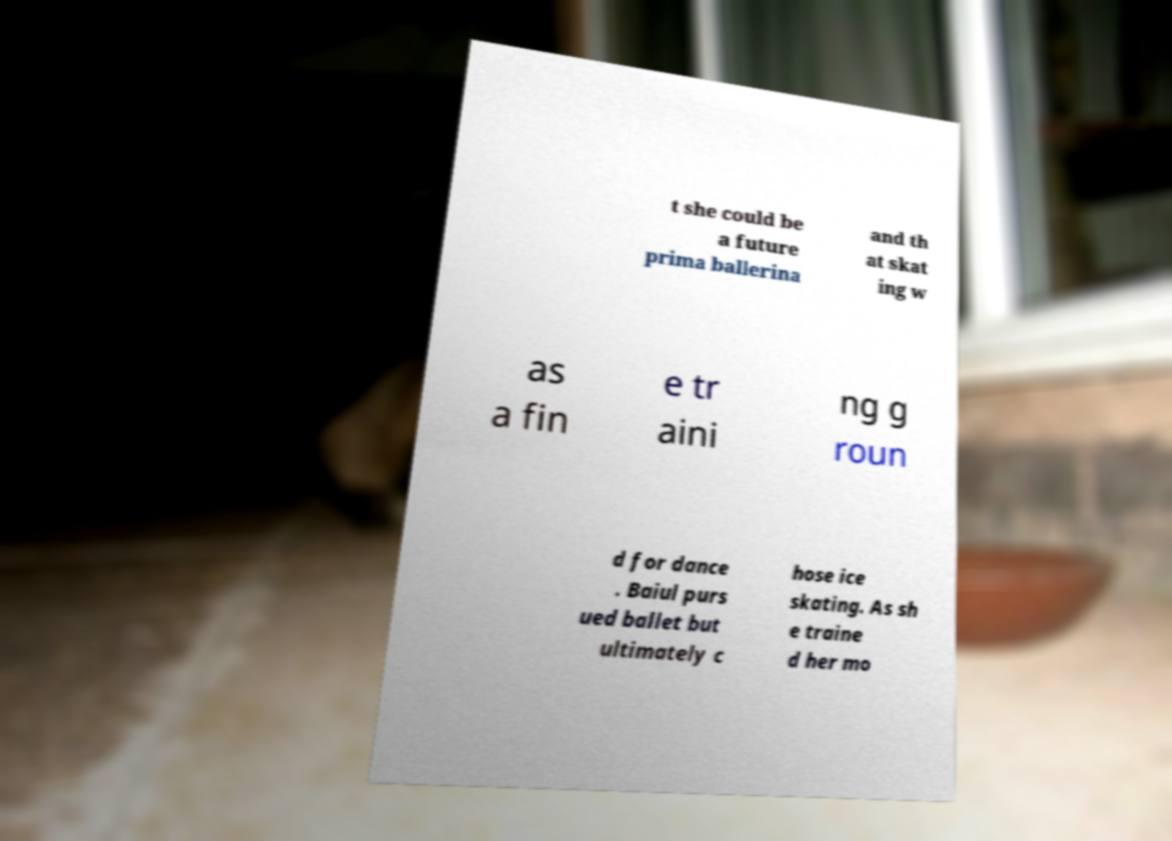For documentation purposes, I need the text within this image transcribed. Could you provide that? t she could be a future prima ballerina and th at skat ing w as a fin e tr aini ng g roun d for dance . Baiul purs ued ballet but ultimately c hose ice skating. As sh e traine d her mo 